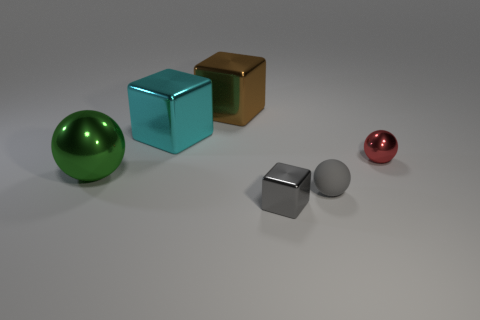What is the size of the metal thing that is the same color as the small matte thing?
Your answer should be compact. Small. Is there a rubber ball of the same color as the tiny metallic cube?
Offer a very short reply. Yes. There is a object that is both to the right of the gray metallic thing and behind the green shiny ball; what is its shape?
Your response must be concise. Sphere. Is the number of green things that are behind the tiny red ball the same as the number of objects to the right of the large brown metallic block?
Offer a terse response. No. How many things are big cyan metal things or red shiny spheres?
Provide a succinct answer. 2. What is the color of the metal cube that is the same size as the gray ball?
Your answer should be very brief. Gray. How many things are either small objects on the right side of the brown cube or objects to the right of the green metal thing?
Offer a terse response. 5. Are there an equal number of gray matte objects that are in front of the red object and large brown shiny blocks?
Your response must be concise. Yes. Is the size of the metal cube that is on the left side of the brown metallic thing the same as the block that is in front of the large cyan cube?
Make the answer very short. No. Are there any large things behind the sphere that is behind the big green ball that is to the left of the rubber thing?
Make the answer very short. Yes. 